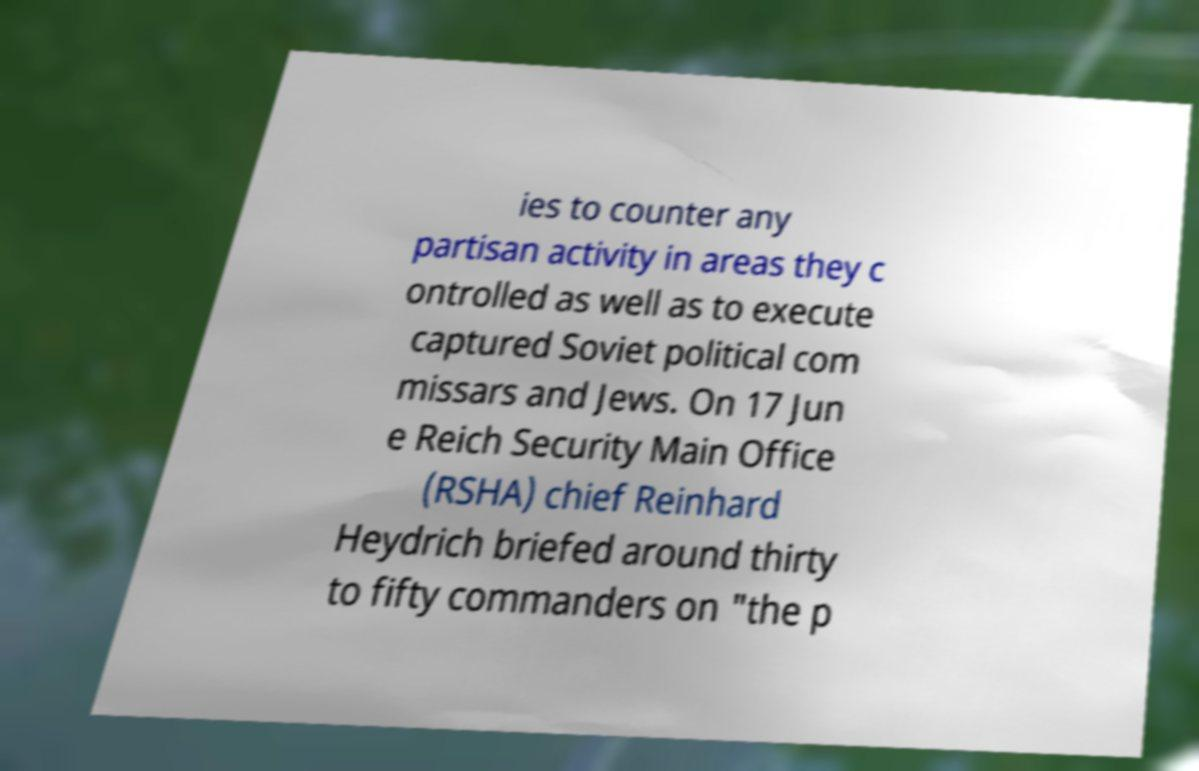There's text embedded in this image that I need extracted. Can you transcribe it verbatim? ies to counter any partisan activity in areas they c ontrolled as well as to execute captured Soviet political com missars and Jews. On 17 Jun e Reich Security Main Office (RSHA) chief Reinhard Heydrich briefed around thirty to fifty commanders on "the p 